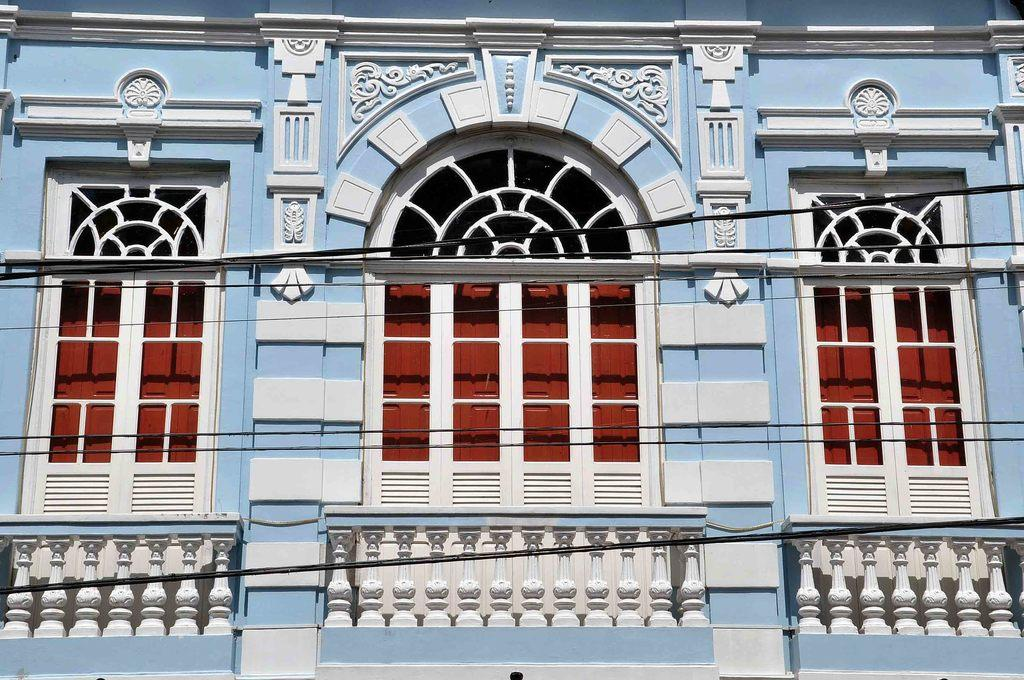What type of structure is present in the image? There is a building in the image. What feature of the building can be seen? The building has windows. What additional object is visible in the image? There is a railing in the image. Are there any other elements visible in the image? Yes, there are wires visible in the image. Can you tell me how many beetles are crawling on the building in the image? There are no beetles present in the image; it only features a building, windows, a railing, and wires. Is there a playground depicted in the image? There is no playground present in the image. 